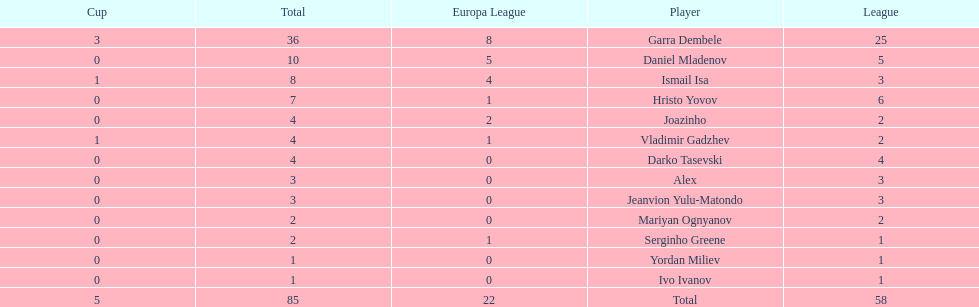Which players only scored one goal? Serginho Greene, Yordan Miliev, Ivo Ivanov. 